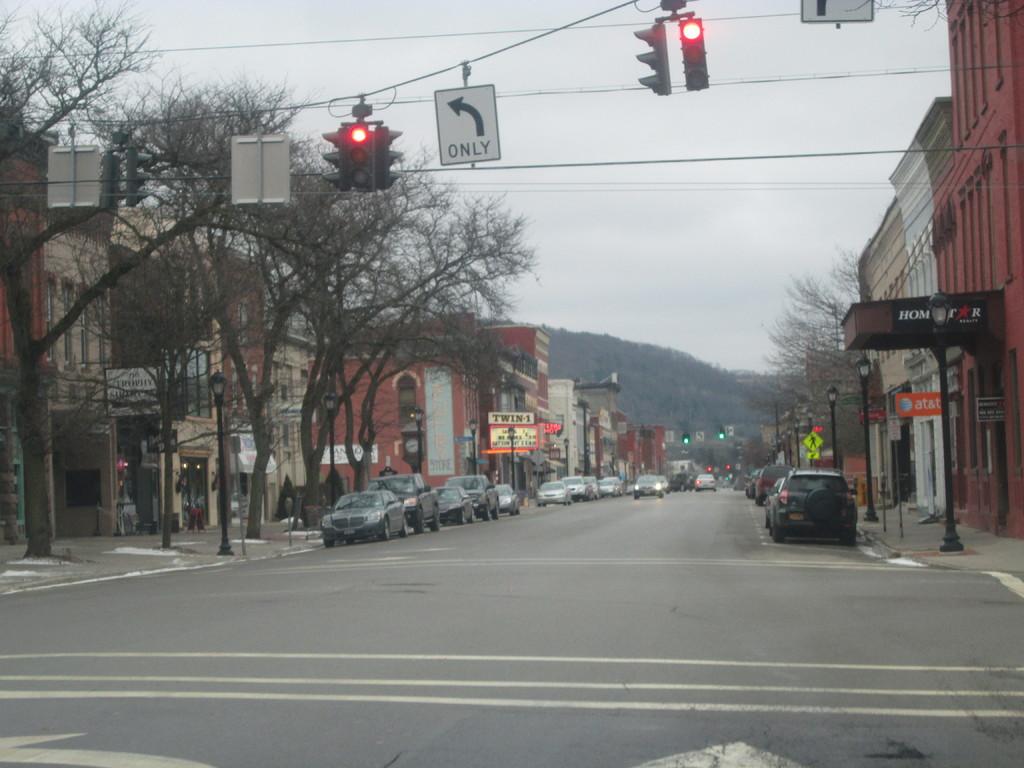What does the sign direct you to do?
Provide a short and direct response. Turn left. 